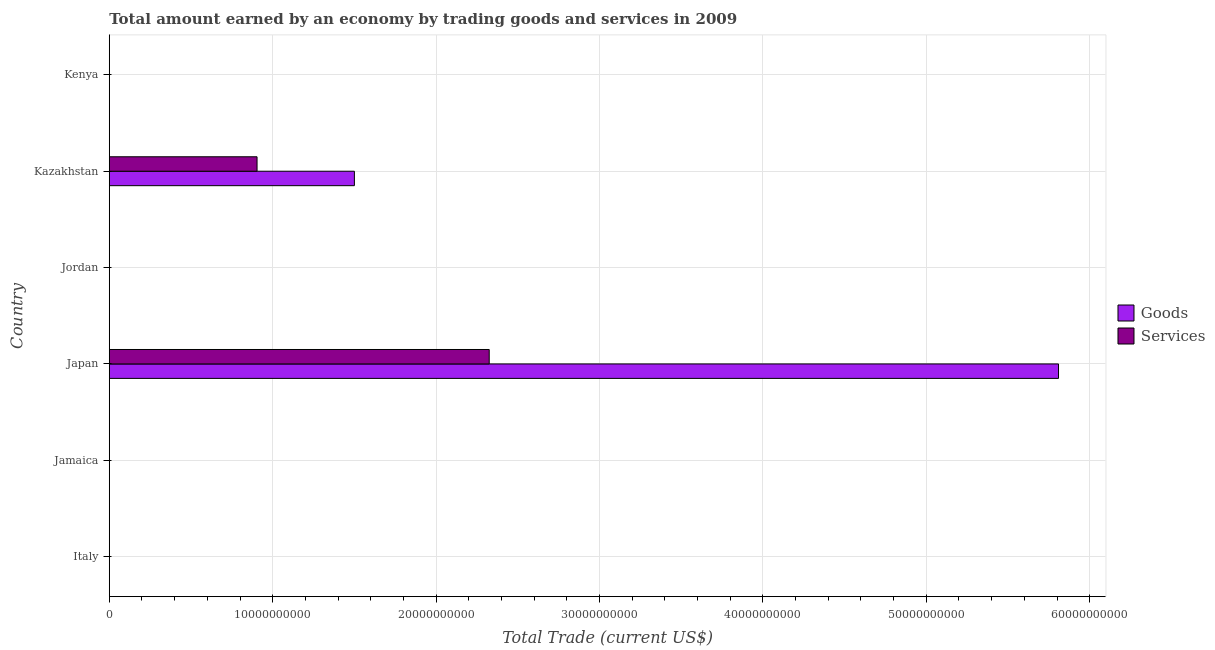How many different coloured bars are there?
Offer a terse response. 2. Are the number of bars per tick equal to the number of legend labels?
Make the answer very short. No. How many bars are there on the 6th tick from the top?
Keep it short and to the point. 0. What is the label of the 1st group of bars from the top?
Keep it short and to the point. Kenya. In how many cases, is the number of bars for a given country not equal to the number of legend labels?
Offer a very short reply. 4. What is the amount earned by trading goods in Jamaica?
Offer a terse response. 0. Across all countries, what is the maximum amount earned by trading goods?
Provide a succinct answer. 5.81e+1. Across all countries, what is the minimum amount earned by trading goods?
Your response must be concise. 0. In which country was the amount earned by trading goods maximum?
Ensure brevity in your answer.  Japan. What is the total amount earned by trading services in the graph?
Keep it short and to the point. 3.23e+1. What is the difference between the amount earned by trading services in Japan and that in Kazakhstan?
Ensure brevity in your answer.  1.42e+1. What is the difference between the amount earned by trading services in Kenya and the amount earned by trading goods in Kazakhstan?
Give a very brief answer. -1.50e+1. What is the average amount earned by trading services per country?
Make the answer very short. 5.38e+09. What is the difference between the amount earned by trading services and amount earned by trading goods in Kazakhstan?
Your answer should be very brief. -5.96e+09. What is the ratio of the amount earned by trading services in Japan to that in Kazakhstan?
Your response must be concise. 2.57. What is the difference between the highest and the lowest amount earned by trading services?
Ensure brevity in your answer.  2.33e+1. Are all the bars in the graph horizontal?
Offer a very short reply. Yes. How many countries are there in the graph?
Keep it short and to the point. 6. Are the values on the major ticks of X-axis written in scientific E-notation?
Your answer should be compact. No. Does the graph contain grids?
Make the answer very short. Yes. Where does the legend appear in the graph?
Your answer should be compact. Center right. What is the title of the graph?
Keep it short and to the point. Total amount earned by an economy by trading goods and services in 2009. What is the label or title of the X-axis?
Your answer should be very brief. Total Trade (current US$). What is the Total Trade (current US$) in Services in Italy?
Offer a terse response. 0. What is the Total Trade (current US$) of Goods in Jamaica?
Keep it short and to the point. 0. What is the Total Trade (current US$) of Goods in Japan?
Offer a very short reply. 5.81e+1. What is the Total Trade (current US$) of Services in Japan?
Your response must be concise. 2.33e+1. What is the Total Trade (current US$) of Services in Jordan?
Provide a succinct answer. 0. What is the Total Trade (current US$) of Goods in Kazakhstan?
Provide a short and direct response. 1.50e+1. What is the Total Trade (current US$) in Services in Kazakhstan?
Offer a very short reply. 9.04e+09. Across all countries, what is the maximum Total Trade (current US$) of Goods?
Offer a very short reply. 5.81e+1. Across all countries, what is the maximum Total Trade (current US$) in Services?
Provide a succinct answer. 2.33e+1. What is the total Total Trade (current US$) in Goods in the graph?
Your response must be concise. 7.31e+1. What is the total Total Trade (current US$) of Services in the graph?
Make the answer very short. 3.23e+1. What is the difference between the Total Trade (current US$) in Goods in Japan and that in Kazakhstan?
Your answer should be compact. 4.31e+1. What is the difference between the Total Trade (current US$) of Services in Japan and that in Kazakhstan?
Provide a succinct answer. 1.42e+1. What is the difference between the Total Trade (current US$) of Goods in Japan and the Total Trade (current US$) of Services in Kazakhstan?
Offer a terse response. 4.90e+1. What is the average Total Trade (current US$) in Goods per country?
Your answer should be very brief. 1.22e+1. What is the average Total Trade (current US$) in Services per country?
Keep it short and to the point. 5.38e+09. What is the difference between the Total Trade (current US$) of Goods and Total Trade (current US$) of Services in Japan?
Offer a very short reply. 3.48e+1. What is the difference between the Total Trade (current US$) of Goods and Total Trade (current US$) of Services in Kazakhstan?
Provide a succinct answer. 5.96e+09. What is the ratio of the Total Trade (current US$) in Goods in Japan to that in Kazakhstan?
Your response must be concise. 3.87. What is the ratio of the Total Trade (current US$) in Services in Japan to that in Kazakhstan?
Give a very brief answer. 2.57. What is the difference between the highest and the lowest Total Trade (current US$) in Goods?
Your answer should be compact. 5.81e+1. What is the difference between the highest and the lowest Total Trade (current US$) of Services?
Make the answer very short. 2.33e+1. 